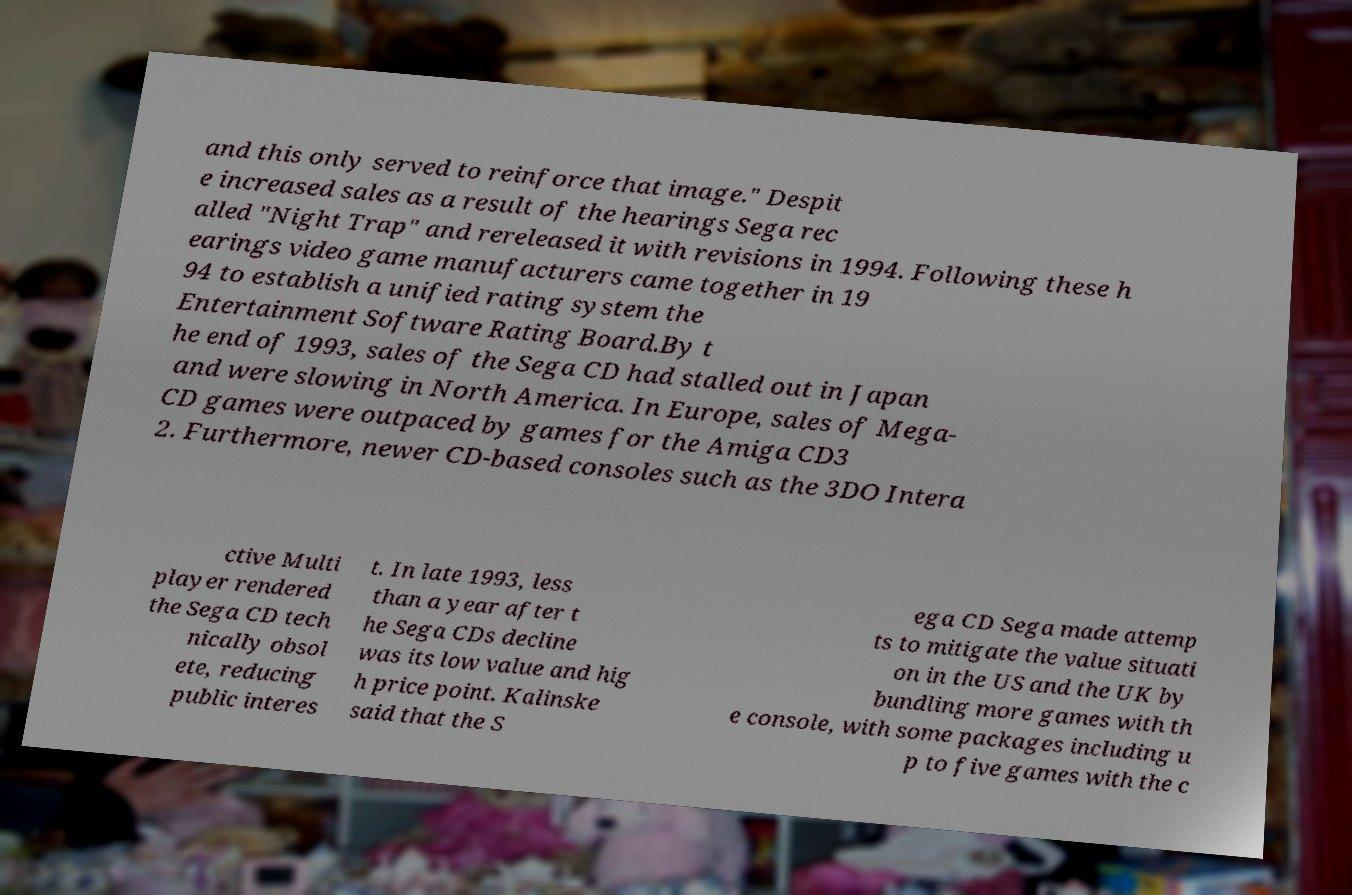Can you read and provide the text displayed in the image?This photo seems to have some interesting text. Can you extract and type it out for me? and this only served to reinforce that image." Despit e increased sales as a result of the hearings Sega rec alled "Night Trap" and rereleased it with revisions in 1994. Following these h earings video game manufacturers came together in 19 94 to establish a unified rating system the Entertainment Software Rating Board.By t he end of 1993, sales of the Sega CD had stalled out in Japan and were slowing in North America. In Europe, sales of Mega- CD games were outpaced by games for the Amiga CD3 2. Furthermore, newer CD-based consoles such as the 3DO Intera ctive Multi player rendered the Sega CD tech nically obsol ete, reducing public interes t. In late 1993, less than a year after t he Sega CDs decline was its low value and hig h price point. Kalinske said that the S ega CD Sega made attemp ts to mitigate the value situati on in the US and the UK by bundling more games with th e console, with some packages including u p to five games with the c 